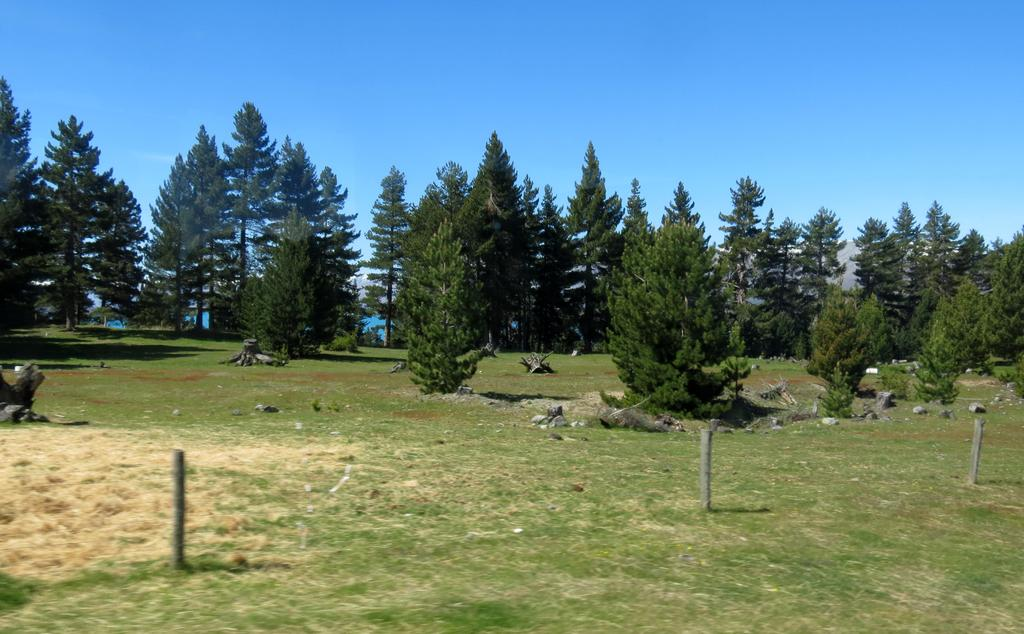What is located at the center of the image? There are poles at the center of the image. What type of surface is visible at the bottom of the image? There is grass on the surface at the bottom of the image. What can be seen in the background of the image? There are trees and the sky visible in the background of the image. How does the grass transport itself to the image? The grass does not transport itself to the image; it is a part of the scene being depicted. What type of growth is observed in the image? The provided facts do not mention any specific type of growth in the image. 